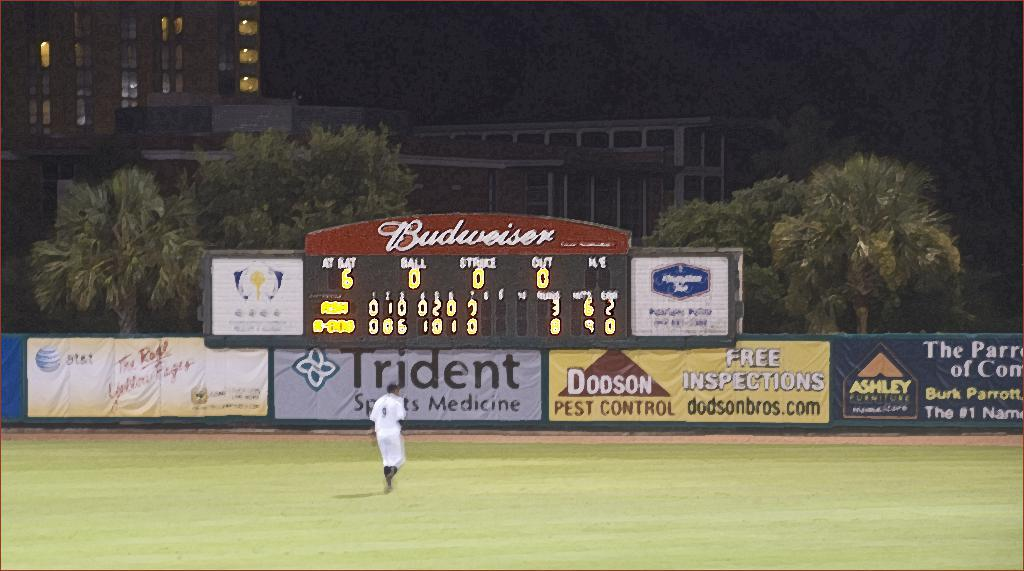<image>
Describe the image concisely. A baseball field with a digital display board the says Budweiser. 